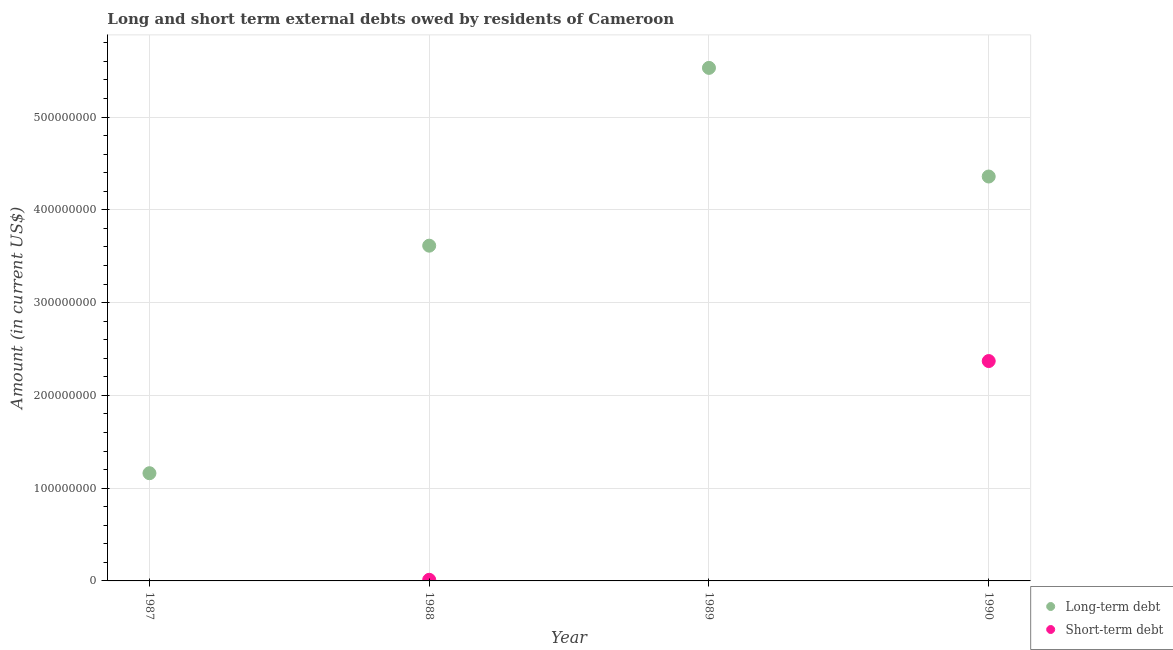Is the number of dotlines equal to the number of legend labels?
Give a very brief answer. No. What is the long-term debts owed by residents in 1990?
Provide a succinct answer. 4.36e+08. Across all years, what is the maximum short-term debts owed by residents?
Offer a very short reply. 2.37e+08. Across all years, what is the minimum long-term debts owed by residents?
Ensure brevity in your answer.  1.16e+08. In which year was the long-term debts owed by residents maximum?
Your response must be concise. 1989. What is the total short-term debts owed by residents in the graph?
Provide a succinct answer. 2.38e+08. What is the difference between the long-term debts owed by residents in 1988 and that in 1990?
Give a very brief answer. -7.46e+07. What is the difference between the short-term debts owed by residents in 1989 and the long-term debts owed by residents in 1988?
Your response must be concise. -3.61e+08. What is the average short-term debts owed by residents per year?
Ensure brevity in your answer.  5.96e+07. In the year 1988, what is the difference between the long-term debts owed by residents and short-term debts owed by residents?
Provide a succinct answer. 3.60e+08. What is the ratio of the long-term debts owed by residents in 1988 to that in 1990?
Provide a succinct answer. 0.83. What is the difference between the highest and the second highest long-term debts owed by residents?
Offer a very short reply. 1.17e+08. What is the difference between the highest and the lowest long-term debts owed by residents?
Give a very brief answer. 4.37e+08. Is the sum of the long-term debts owed by residents in 1987 and 1990 greater than the maximum short-term debts owed by residents across all years?
Keep it short and to the point. Yes. Does the short-term debts owed by residents monotonically increase over the years?
Your answer should be compact. No. Is the long-term debts owed by residents strictly greater than the short-term debts owed by residents over the years?
Keep it short and to the point. Yes. Is the long-term debts owed by residents strictly less than the short-term debts owed by residents over the years?
Your answer should be very brief. No. Are the values on the major ticks of Y-axis written in scientific E-notation?
Make the answer very short. No. Does the graph contain grids?
Provide a succinct answer. Yes. What is the title of the graph?
Your answer should be compact. Long and short term external debts owed by residents of Cameroon. Does "Domestic liabilities" appear as one of the legend labels in the graph?
Give a very brief answer. No. What is the label or title of the Y-axis?
Ensure brevity in your answer.  Amount (in current US$). What is the Amount (in current US$) in Long-term debt in 1987?
Your answer should be very brief. 1.16e+08. What is the Amount (in current US$) of Long-term debt in 1988?
Your answer should be very brief. 3.61e+08. What is the Amount (in current US$) in Short-term debt in 1988?
Keep it short and to the point. 1.20e+06. What is the Amount (in current US$) in Long-term debt in 1989?
Ensure brevity in your answer.  5.53e+08. What is the Amount (in current US$) in Long-term debt in 1990?
Keep it short and to the point. 4.36e+08. What is the Amount (in current US$) in Short-term debt in 1990?
Your answer should be compact. 2.37e+08. Across all years, what is the maximum Amount (in current US$) in Long-term debt?
Provide a short and direct response. 5.53e+08. Across all years, what is the maximum Amount (in current US$) of Short-term debt?
Ensure brevity in your answer.  2.37e+08. Across all years, what is the minimum Amount (in current US$) of Long-term debt?
Your answer should be very brief. 1.16e+08. What is the total Amount (in current US$) in Long-term debt in the graph?
Offer a very short reply. 1.47e+09. What is the total Amount (in current US$) in Short-term debt in the graph?
Offer a very short reply. 2.38e+08. What is the difference between the Amount (in current US$) of Long-term debt in 1987 and that in 1988?
Keep it short and to the point. -2.45e+08. What is the difference between the Amount (in current US$) in Long-term debt in 1987 and that in 1989?
Give a very brief answer. -4.37e+08. What is the difference between the Amount (in current US$) of Long-term debt in 1987 and that in 1990?
Make the answer very short. -3.20e+08. What is the difference between the Amount (in current US$) in Long-term debt in 1988 and that in 1989?
Your answer should be compact. -1.92e+08. What is the difference between the Amount (in current US$) of Long-term debt in 1988 and that in 1990?
Offer a very short reply. -7.46e+07. What is the difference between the Amount (in current US$) of Short-term debt in 1988 and that in 1990?
Your answer should be very brief. -2.36e+08. What is the difference between the Amount (in current US$) in Long-term debt in 1989 and that in 1990?
Your answer should be compact. 1.17e+08. What is the difference between the Amount (in current US$) in Long-term debt in 1987 and the Amount (in current US$) in Short-term debt in 1988?
Provide a short and direct response. 1.15e+08. What is the difference between the Amount (in current US$) in Long-term debt in 1987 and the Amount (in current US$) in Short-term debt in 1990?
Ensure brevity in your answer.  -1.21e+08. What is the difference between the Amount (in current US$) of Long-term debt in 1988 and the Amount (in current US$) of Short-term debt in 1990?
Provide a succinct answer. 1.24e+08. What is the difference between the Amount (in current US$) in Long-term debt in 1989 and the Amount (in current US$) in Short-term debt in 1990?
Provide a succinct answer. 3.16e+08. What is the average Amount (in current US$) in Long-term debt per year?
Keep it short and to the point. 3.67e+08. What is the average Amount (in current US$) in Short-term debt per year?
Your response must be concise. 5.96e+07. In the year 1988, what is the difference between the Amount (in current US$) of Long-term debt and Amount (in current US$) of Short-term debt?
Offer a terse response. 3.60e+08. In the year 1990, what is the difference between the Amount (in current US$) of Long-term debt and Amount (in current US$) of Short-term debt?
Keep it short and to the point. 1.99e+08. What is the ratio of the Amount (in current US$) in Long-term debt in 1987 to that in 1988?
Keep it short and to the point. 0.32. What is the ratio of the Amount (in current US$) in Long-term debt in 1987 to that in 1989?
Your answer should be compact. 0.21. What is the ratio of the Amount (in current US$) of Long-term debt in 1987 to that in 1990?
Offer a terse response. 0.27. What is the ratio of the Amount (in current US$) of Long-term debt in 1988 to that in 1989?
Give a very brief answer. 0.65. What is the ratio of the Amount (in current US$) in Long-term debt in 1988 to that in 1990?
Ensure brevity in your answer.  0.83. What is the ratio of the Amount (in current US$) of Short-term debt in 1988 to that in 1990?
Provide a succinct answer. 0.01. What is the ratio of the Amount (in current US$) of Long-term debt in 1989 to that in 1990?
Offer a terse response. 1.27. What is the difference between the highest and the second highest Amount (in current US$) in Long-term debt?
Make the answer very short. 1.17e+08. What is the difference between the highest and the lowest Amount (in current US$) of Long-term debt?
Keep it short and to the point. 4.37e+08. What is the difference between the highest and the lowest Amount (in current US$) in Short-term debt?
Offer a very short reply. 2.37e+08. 